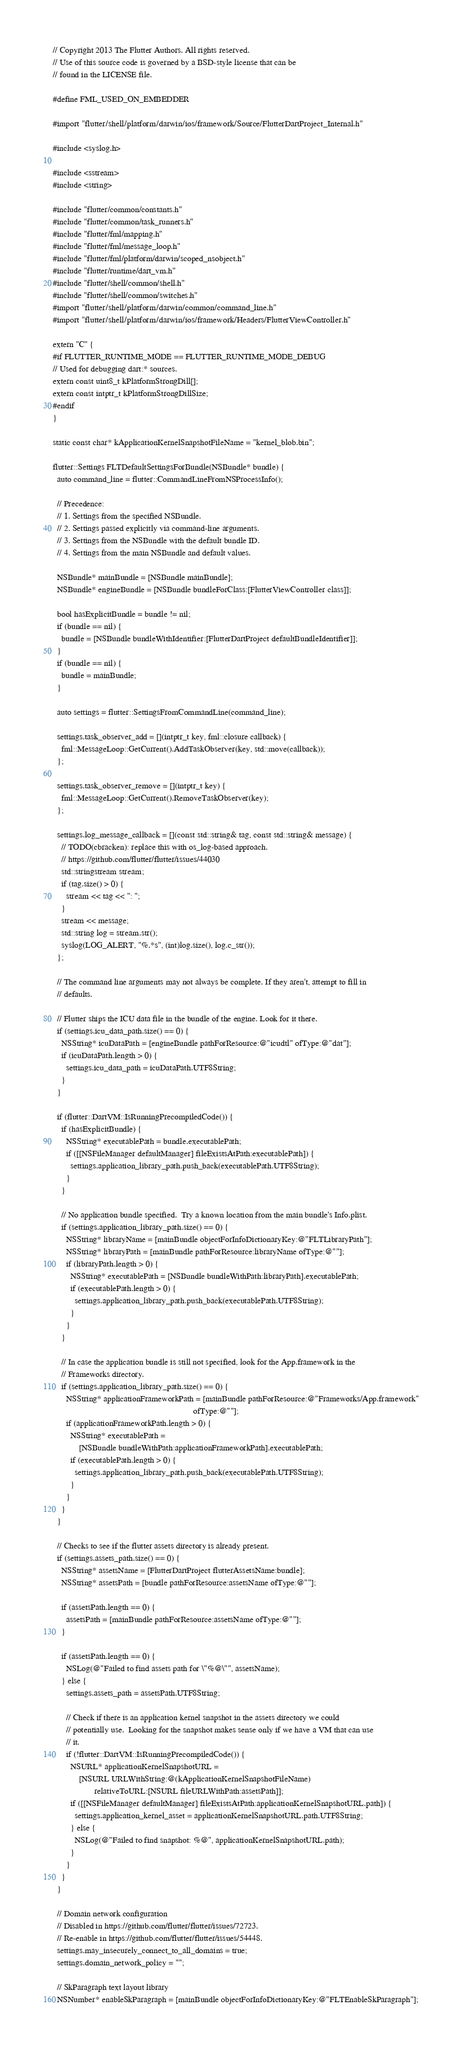Convert code to text. <code><loc_0><loc_0><loc_500><loc_500><_ObjectiveC_>// Copyright 2013 The Flutter Authors. All rights reserved.
// Use of this source code is governed by a BSD-style license that can be
// found in the LICENSE file.

#define FML_USED_ON_EMBEDDER

#import "flutter/shell/platform/darwin/ios/framework/Source/FlutterDartProject_Internal.h"

#include <syslog.h>

#include <sstream>
#include <string>

#include "flutter/common/constants.h"
#include "flutter/common/task_runners.h"
#include "flutter/fml/mapping.h"
#include "flutter/fml/message_loop.h"
#include "flutter/fml/platform/darwin/scoped_nsobject.h"
#include "flutter/runtime/dart_vm.h"
#include "flutter/shell/common/shell.h"
#include "flutter/shell/common/switches.h"
#import "flutter/shell/platform/darwin/common/command_line.h"
#import "flutter/shell/platform/darwin/ios/framework/Headers/FlutterViewController.h"

extern "C" {
#if FLUTTER_RUNTIME_MODE == FLUTTER_RUNTIME_MODE_DEBUG
// Used for debugging dart:* sources.
extern const uint8_t kPlatformStrongDill[];
extern const intptr_t kPlatformStrongDillSize;
#endif
}

static const char* kApplicationKernelSnapshotFileName = "kernel_blob.bin";

flutter::Settings FLTDefaultSettingsForBundle(NSBundle* bundle) {
  auto command_line = flutter::CommandLineFromNSProcessInfo();

  // Precedence:
  // 1. Settings from the specified NSBundle.
  // 2. Settings passed explicitly via command-line arguments.
  // 3. Settings from the NSBundle with the default bundle ID.
  // 4. Settings from the main NSBundle and default values.

  NSBundle* mainBundle = [NSBundle mainBundle];
  NSBundle* engineBundle = [NSBundle bundleForClass:[FlutterViewController class]];

  bool hasExplicitBundle = bundle != nil;
  if (bundle == nil) {
    bundle = [NSBundle bundleWithIdentifier:[FlutterDartProject defaultBundleIdentifier]];
  }
  if (bundle == nil) {
    bundle = mainBundle;
  }

  auto settings = flutter::SettingsFromCommandLine(command_line);

  settings.task_observer_add = [](intptr_t key, fml::closure callback) {
    fml::MessageLoop::GetCurrent().AddTaskObserver(key, std::move(callback));
  };

  settings.task_observer_remove = [](intptr_t key) {
    fml::MessageLoop::GetCurrent().RemoveTaskObserver(key);
  };

  settings.log_message_callback = [](const std::string& tag, const std::string& message) {
    // TODO(cbracken): replace this with os_log-based approach.
    // https://github.com/flutter/flutter/issues/44030
    std::stringstream stream;
    if (tag.size() > 0) {
      stream << tag << ": ";
    }
    stream << message;
    std::string log = stream.str();
    syslog(LOG_ALERT, "%.*s", (int)log.size(), log.c_str());
  };

  // The command line arguments may not always be complete. If they aren't, attempt to fill in
  // defaults.

  // Flutter ships the ICU data file in the bundle of the engine. Look for it there.
  if (settings.icu_data_path.size() == 0) {
    NSString* icuDataPath = [engineBundle pathForResource:@"icudtl" ofType:@"dat"];
    if (icuDataPath.length > 0) {
      settings.icu_data_path = icuDataPath.UTF8String;
    }
  }

  if (flutter::DartVM::IsRunningPrecompiledCode()) {
    if (hasExplicitBundle) {
      NSString* executablePath = bundle.executablePath;
      if ([[NSFileManager defaultManager] fileExistsAtPath:executablePath]) {
        settings.application_library_path.push_back(executablePath.UTF8String);
      }
    }

    // No application bundle specified.  Try a known location from the main bundle's Info.plist.
    if (settings.application_library_path.size() == 0) {
      NSString* libraryName = [mainBundle objectForInfoDictionaryKey:@"FLTLibraryPath"];
      NSString* libraryPath = [mainBundle pathForResource:libraryName ofType:@""];
      if (libraryPath.length > 0) {
        NSString* executablePath = [NSBundle bundleWithPath:libraryPath].executablePath;
        if (executablePath.length > 0) {
          settings.application_library_path.push_back(executablePath.UTF8String);
        }
      }
    }

    // In case the application bundle is still not specified, look for the App.framework in the
    // Frameworks directory.
    if (settings.application_library_path.size() == 0) {
      NSString* applicationFrameworkPath = [mainBundle pathForResource:@"Frameworks/App.framework"
                                                                ofType:@""];
      if (applicationFrameworkPath.length > 0) {
        NSString* executablePath =
            [NSBundle bundleWithPath:applicationFrameworkPath].executablePath;
        if (executablePath.length > 0) {
          settings.application_library_path.push_back(executablePath.UTF8String);
        }
      }
    }
  }

  // Checks to see if the flutter assets directory is already present.
  if (settings.assets_path.size() == 0) {
    NSString* assetsName = [FlutterDartProject flutterAssetsName:bundle];
    NSString* assetsPath = [bundle pathForResource:assetsName ofType:@""];

    if (assetsPath.length == 0) {
      assetsPath = [mainBundle pathForResource:assetsName ofType:@""];
    }

    if (assetsPath.length == 0) {
      NSLog(@"Failed to find assets path for \"%@\"", assetsName);
    } else {
      settings.assets_path = assetsPath.UTF8String;

      // Check if there is an application kernel snapshot in the assets directory we could
      // potentially use.  Looking for the snapshot makes sense only if we have a VM that can use
      // it.
      if (!flutter::DartVM::IsRunningPrecompiledCode()) {
        NSURL* applicationKernelSnapshotURL =
            [NSURL URLWithString:@(kApplicationKernelSnapshotFileName)
                   relativeToURL:[NSURL fileURLWithPath:assetsPath]];
        if ([[NSFileManager defaultManager] fileExistsAtPath:applicationKernelSnapshotURL.path]) {
          settings.application_kernel_asset = applicationKernelSnapshotURL.path.UTF8String;
        } else {
          NSLog(@"Failed to find snapshot: %@", applicationKernelSnapshotURL.path);
        }
      }
    }
  }

  // Domain network configuration
  // Disabled in https://github.com/flutter/flutter/issues/72723.
  // Re-enable in https://github.com/flutter/flutter/issues/54448.
  settings.may_insecurely_connect_to_all_domains = true;
  settings.domain_network_policy = "";

  // SkParagraph text layout library
  NSNumber* enableSkParagraph = [mainBundle objectForInfoDictionaryKey:@"FLTEnableSkParagraph"];</code> 